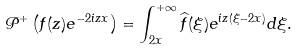Convert formula to latex. <formula><loc_0><loc_0><loc_500><loc_500>& \mathcal { P } ^ { + } \left ( f ( z ) e ^ { - 2 i z x } \right ) = \int _ { 2 x } ^ { + \infty } \widehat { f } ( \xi ) e ^ { i z ( \xi - 2 x ) } d \xi .</formula> 